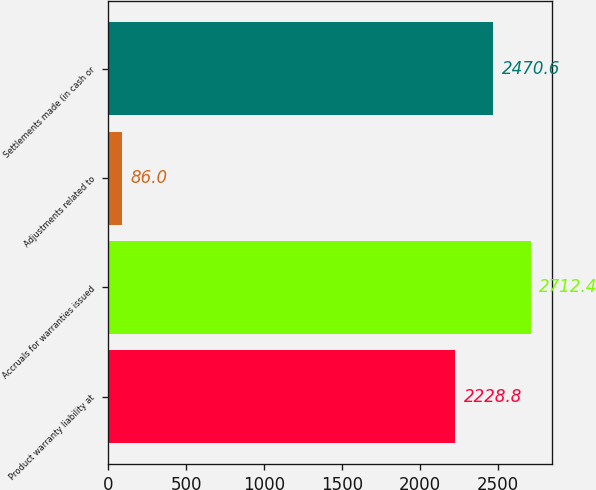Convert chart to OTSL. <chart><loc_0><loc_0><loc_500><loc_500><bar_chart><fcel>Product warranty liability at<fcel>Accruals for warranties issued<fcel>Adjustments related to<fcel>Settlements made (in cash or<nl><fcel>2228.8<fcel>2712.4<fcel>86<fcel>2470.6<nl></chart> 